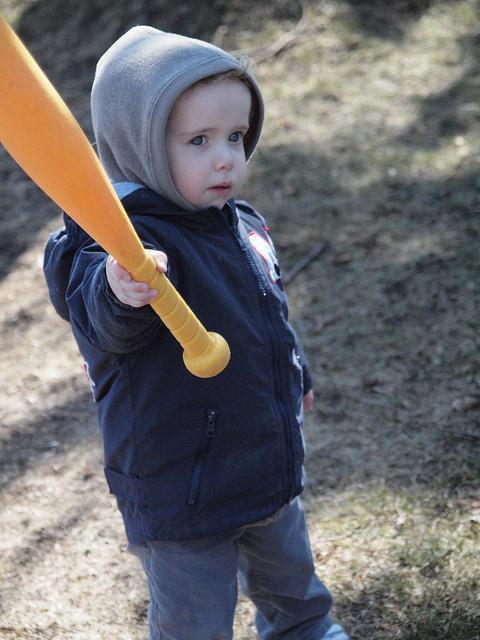How many boat on the seasore?
Give a very brief answer. 0. 